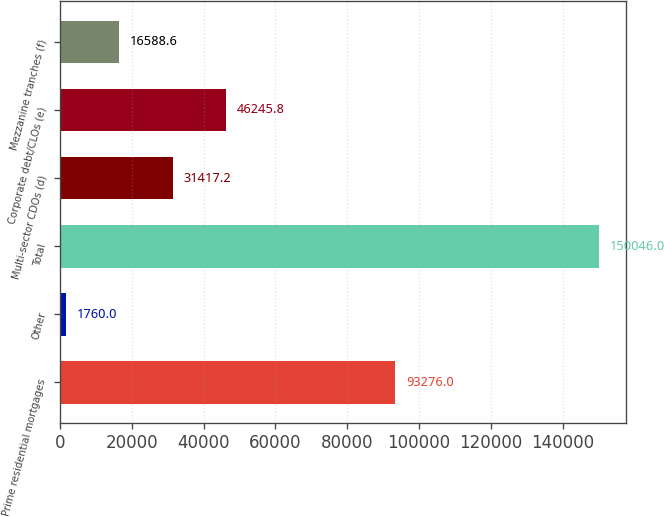<chart> <loc_0><loc_0><loc_500><loc_500><bar_chart><fcel>Prime residential mortgages<fcel>Other<fcel>Total<fcel>Multi-sector CDOs (d)<fcel>Corporate debt/CLOs (e)<fcel>Mezzanine tranches (f)<nl><fcel>93276<fcel>1760<fcel>150046<fcel>31417.2<fcel>46245.8<fcel>16588.6<nl></chart> 